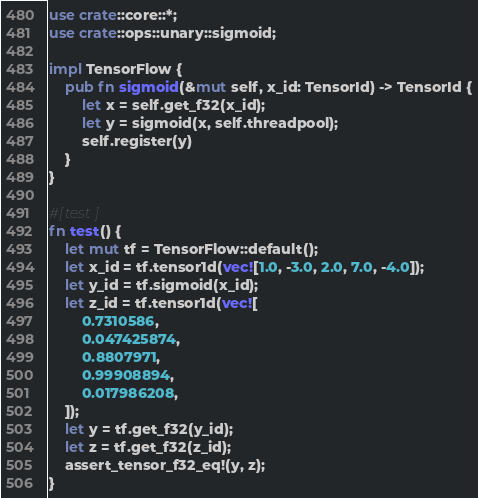Convert code to text. <code><loc_0><loc_0><loc_500><loc_500><_Rust_>use crate::core::*;
use crate::ops::unary::sigmoid;

impl TensorFlow {
    pub fn sigmoid(&mut self, x_id: TensorId) -> TensorId {
        let x = self.get_f32(x_id);
        let y = sigmoid(x, self.threadpool);
        self.register(y)
    }
}

#[test]
fn test() {
    let mut tf = TensorFlow::default();
    let x_id = tf.tensor1d(vec![1.0, -3.0, 2.0, 7.0, -4.0]);
    let y_id = tf.sigmoid(x_id);
    let z_id = tf.tensor1d(vec![
        0.7310586,
        0.047425874,
        0.8807971,
        0.99908894,
        0.017986208,
    ]);
    let y = tf.get_f32(y_id);
    let z = tf.get_f32(z_id);
    assert_tensor_f32_eq!(y, z);
}
</code> 